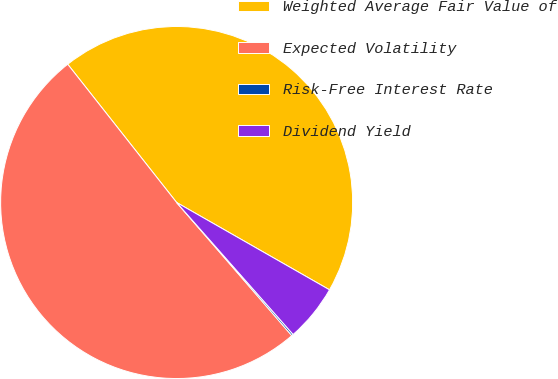<chart> <loc_0><loc_0><loc_500><loc_500><pie_chart><fcel>Weighted Average Fair Value of<fcel>Expected Volatility<fcel>Risk-Free Interest Rate<fcel>Dividend Yield<nl><fcel>43.88%<fcel>50.73%<fcel>0.16%<fcel>5.23%<nl></chart> 